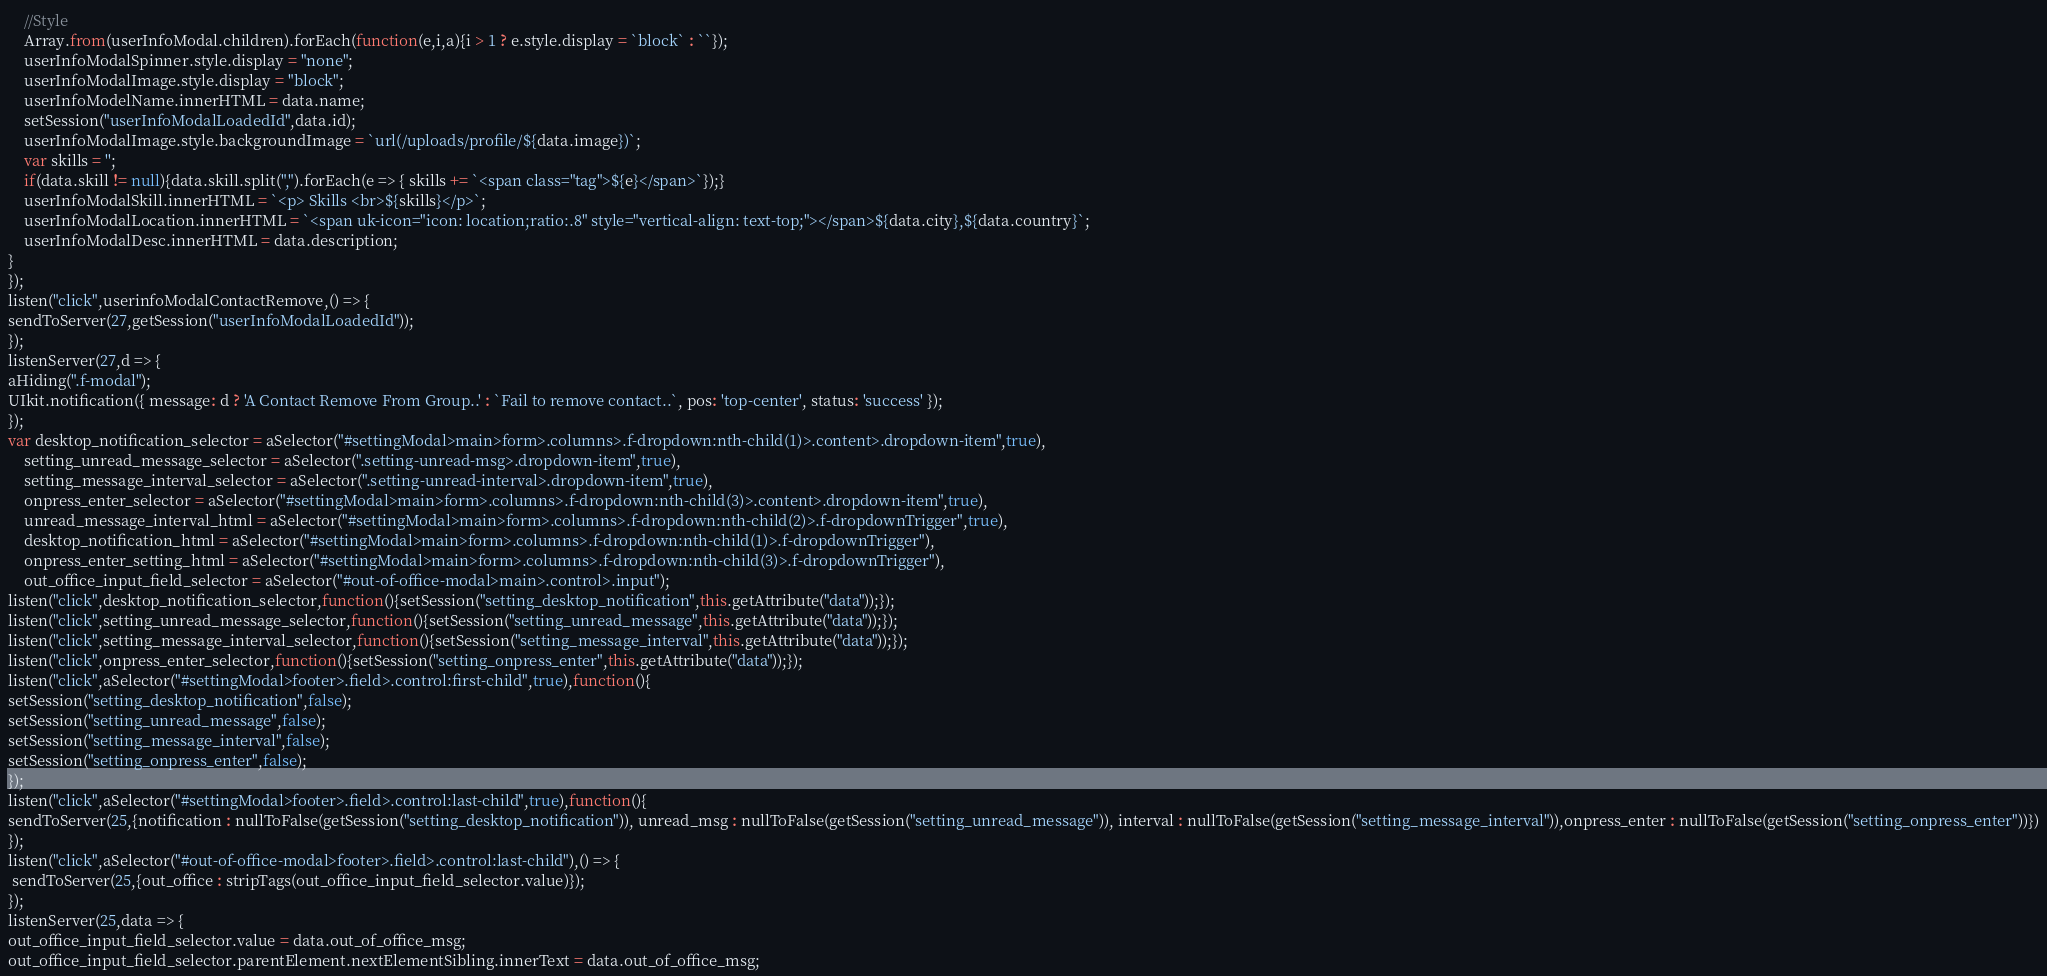<code> <loc_0><loc_0><loc_500><loc_500><_JavaScript_>    //Style
    Array.from(userInfoModal.children).forEach(function(e,i,a){i > 1 ? e.style.display = `block` : ``});
    userInfoModalSpinner.style.display = "none";
    userInfoModalImage.style.display = "block";
    userInfoModelName.innerHTML = data.name;
    setSession("userInfoModalLoadedId",data.id);    
    userInfoModalImage.style.backgroundImage = `url(/uploads/profile/${data.image})`;
    var skills = '';
    if(data.skill != null){data.skill.split(",").forEach(e => { skills += `<span class="tag">${e}</span>`});}
    userInfoModalSkill.innerHTML = `<p> Skills <br>${skills}</p>`;
    userInfoModalLocation.innerHTML = `<span uk-icon="icon: location;ratio:.8" style="vertical-align: text-top;"></span>${data.city},${data.country}`;
    userInfoModalDesc.innerHTML = data.description;
}
});
listen("click",userinfoModalContactRemove,() => {
sendToServer(27,getSession("userInfoModalLoadedId"));
});
listenServer(27,d => {
aHiding(".f-modal");
UIkit.notification({ message: d ? 'A Contact Remove From Group..' : `Fail to remove contact..`, pos: 'top-center', status: 'success' });
});
var desktop_notification_selector = aSelector("#settingModal>main>form>.columns>.f-dropdown:nth-child(1)>.content>.dropdown-item",true),
    setting_unread_message_selector = aSelector(".setting-unread-msg>.dropdown-item",true),
    setting_message_interval_selector = aSelector(".setting-unread-interval>.dropdown-item",true),
    onpress_enter_selector = aSelector("#settingModal>main>form>.columns>.f-dropdown:nth-child(3)>.content>.dropdown-item",true),
    unread_message_interval_html = aSelector("#settingModal>main>form>.columns>.f-dropdown:nth-child(2)>.f-dropdownTrigger",true),    
    desktop_notification_html = aSelector("#settingModal>main>form>.columns>.f-dropdown:nth-child(1)>.f-dropdownTrigger"),
    onpress_enter_setting_html = aSelector("#settingModal>main>form>.columns>.f-dropdown:nth-child(3)>.f-dropdownTrigger"),
    out_office_input_field_selector = aSelector("#out-of-office-modal>main>.control>.input");
listen("click",desktop_notification_selector,function(){setSession("setting_desktop_notification",this.getAttribute("data"));});
listen("click",setting_unread_message_selector,function(){setSession("setting_unread_message",this.getAttribute("data"));});
listen("click",setting_message_interval_selector,function(){setSession("setting_message_interval",this.getAttribute("data"));});
listen("click",onpress_enter_selector,function(){setSession("setting_onpress_enter",this.getAttribute("data"));});
listen("click",aSelector("#settingModal>footer>.field>.control:first-child",true),function(){
setSession("setting_desktop_notification",false);
setSession("setting_unread_message",false);
setSession("setting_message_interval",false);
setSession("setting_onpress_enter",false);
});
listen("click",aSelector("#settingModal>footer>.field>.control:last-child",true),function(){
sendToServer(25,{notification : nullToFalse(getSession("setting_desktop_notification")), unread_msg : nullToFalse(getSession("setting_unread_message")), interval : nullToFalse(getSession("setting_message_interval")),onpress_enter : nullToFalse(getSession("setting_onpress_enter"))})
});
listen("click",aSelector("#out-of-office-modal>footer>.field>.control:last-child"),() => {
 sendToServer(25,{out_office : stripTags(out_office_input_field_selector.value)});
});
listenServer(25,data => {
out_office_input_field_selector.value = data.out_of_office_msg;
out_office_input_field_selector.parentElement.nextElementSibling.innerText = data.out_of_office_msg;</code> 